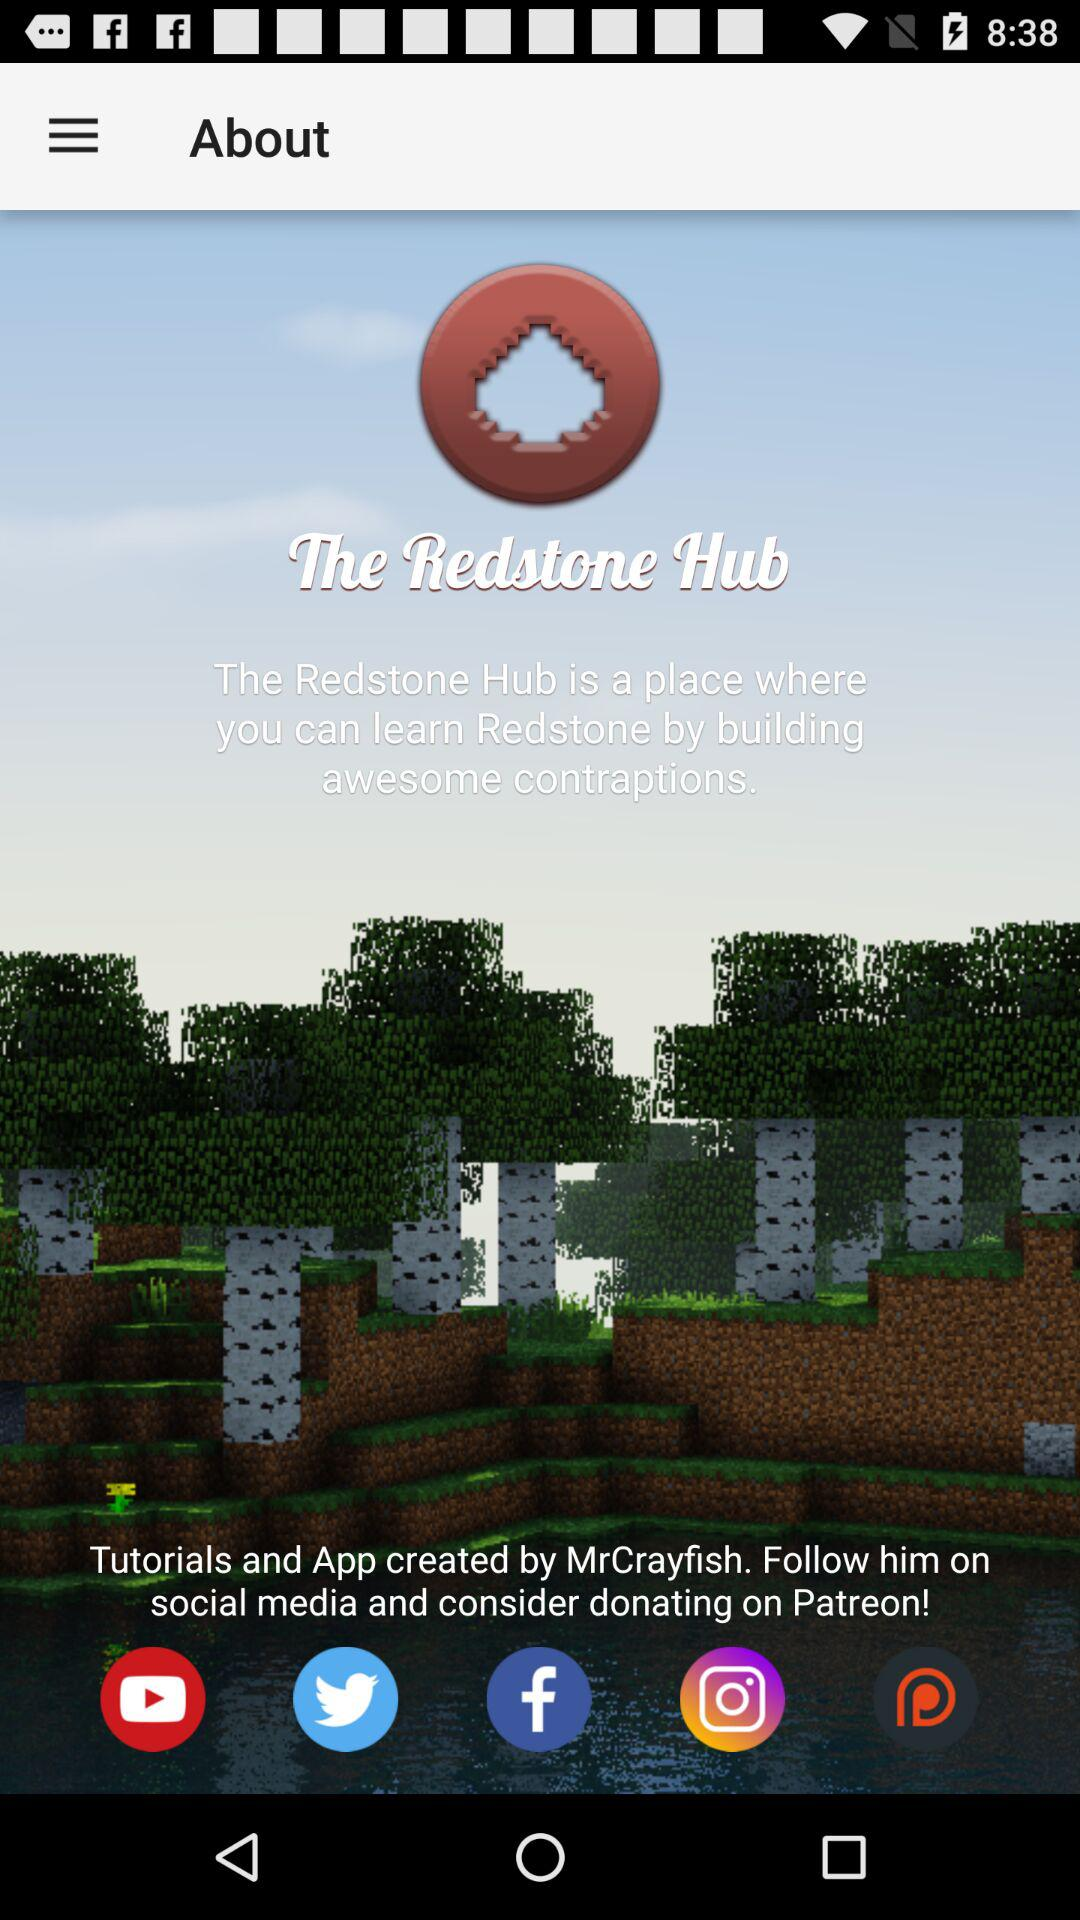Who created the tutorials and applications? The tutorials and applications is created by MrCrayfish. 